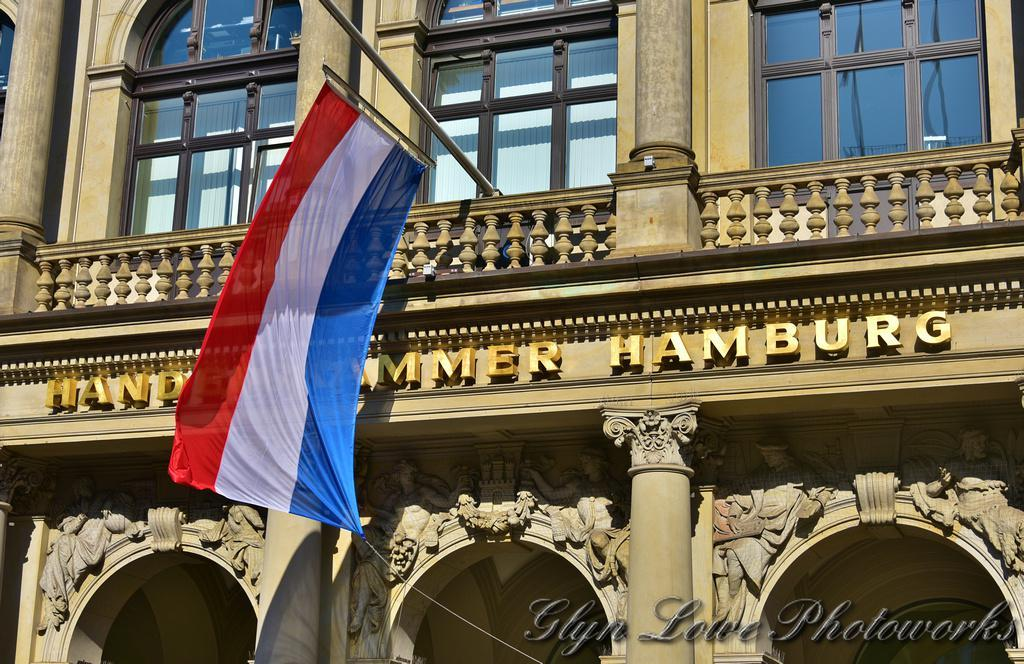What type of structure is visible in the image? There is a building in the image. What feature can be seen on the building? The building has windows. Is there any symbol or sign on the building? Yes, there is a flag on the building. What is written on the flag? The flag has the word "HAMBURG" written on it. How many basketballs can be seen in the image? There are no basketballs present in the image. What type of base is supporting the building in the image? The image does not show the base of the building, so it cannot be determined from the image. 